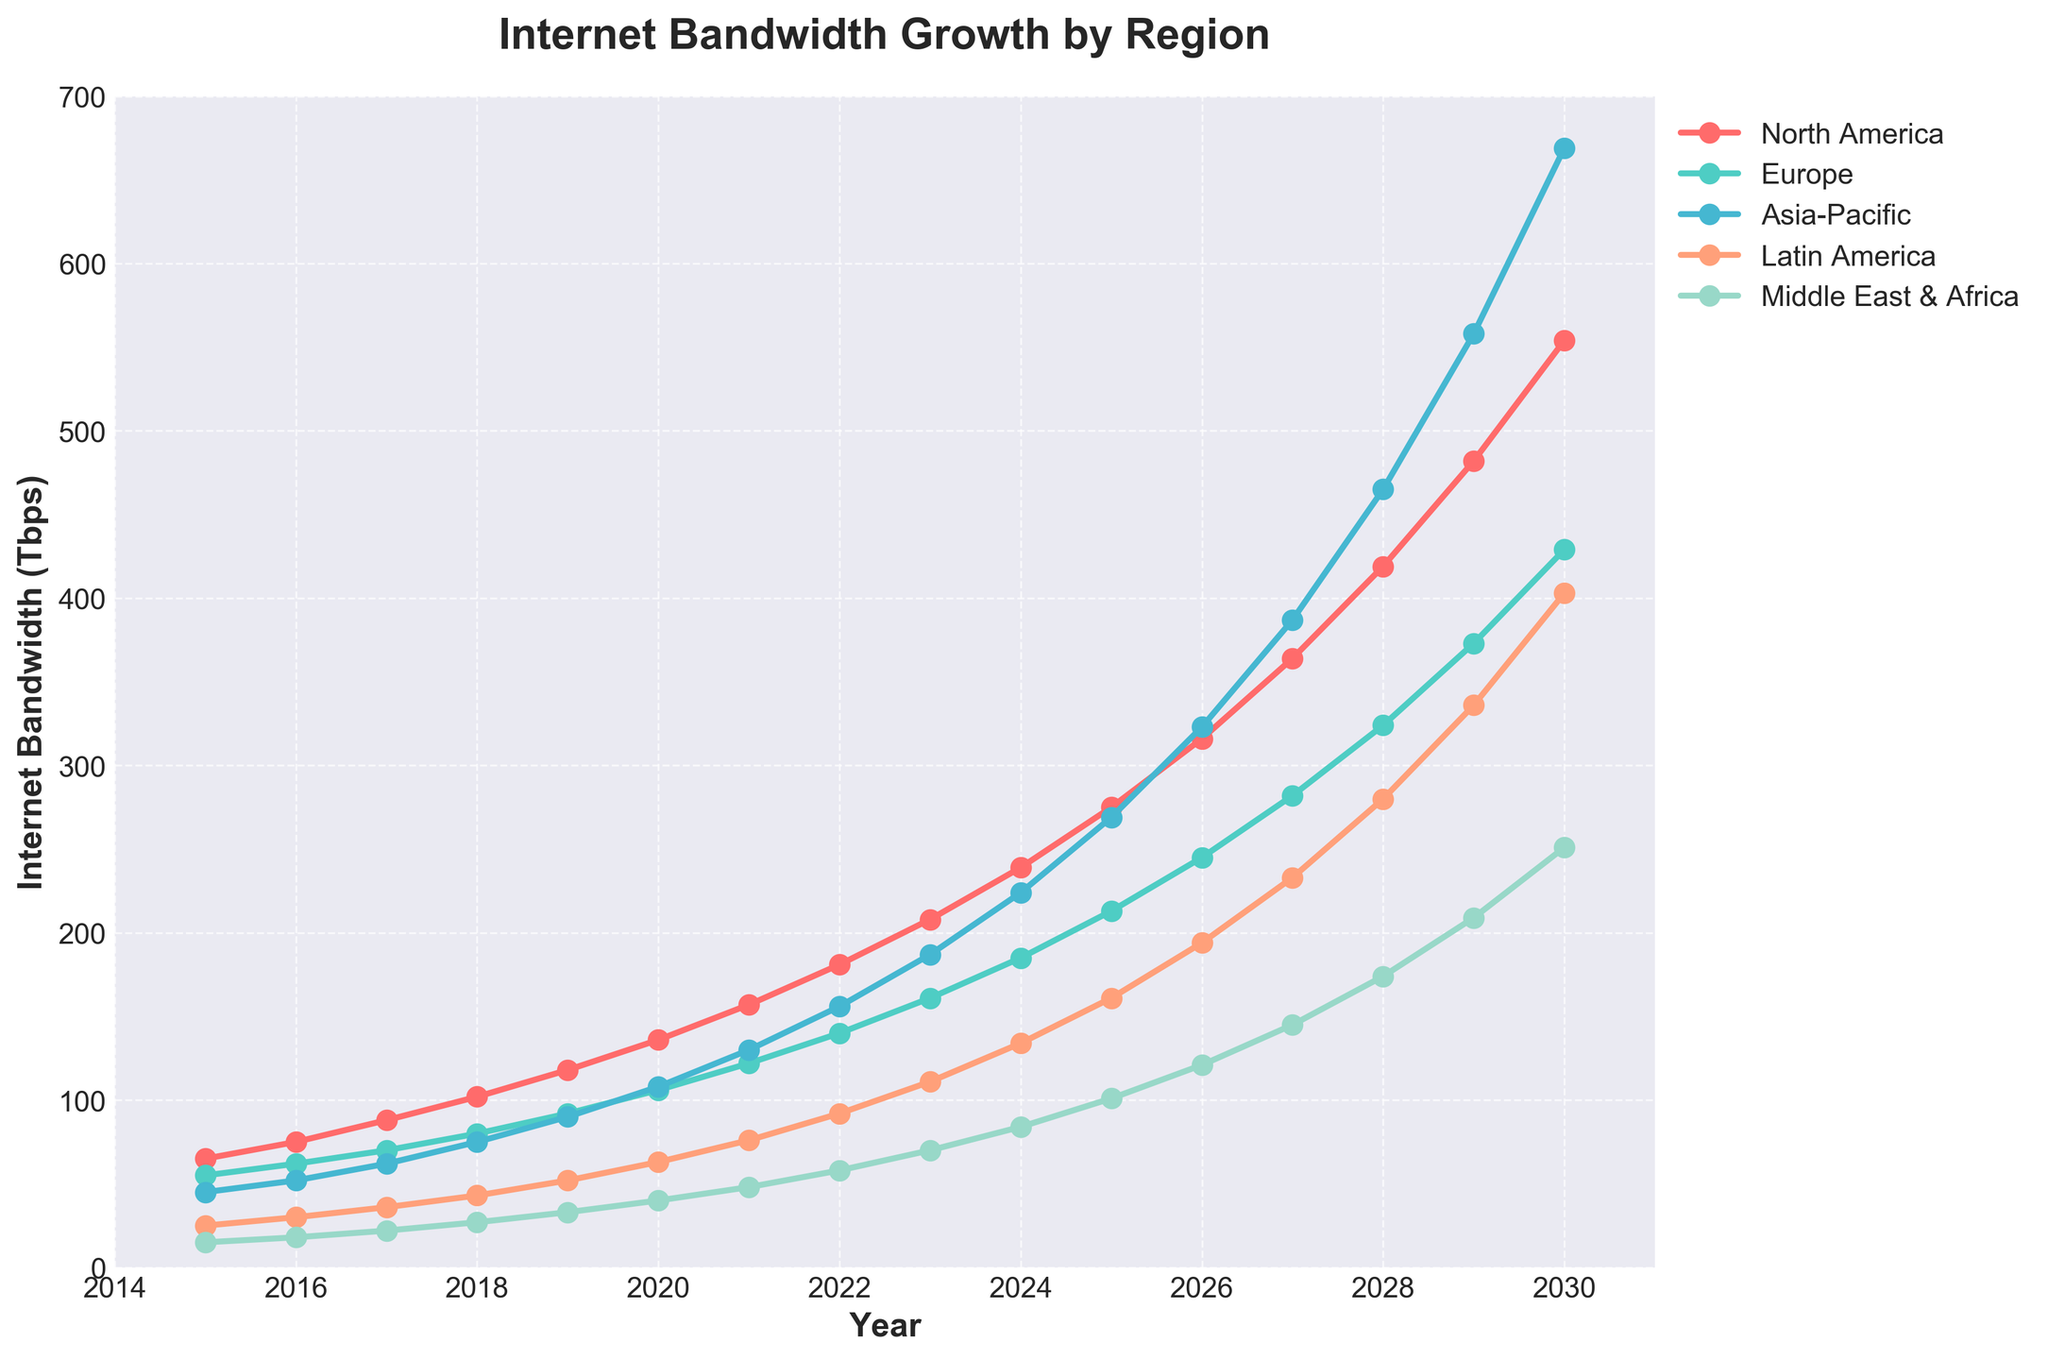What is the overall trend in internet bandwidth for all regions from 2015 to 2030? To determine the overall trend, observe the line graph. All regions show an upward trajectory over the years, indicating a consistent increase in internet bandwidth for each region.
Answer: Upward Which region shows the highest growth in internet bandwidth from 2015 to 2030? To identify this, look at the final values of each region in 2030 and compare them. North America ends at 554 Tbps, Europe at 429 Tbps, Asia-Pacific at 669 Tbps, Latin America at 403 Tbps, and Middle East & Africa at 251 Tbps. Asia-Pacific has the highest value.
Answer: Asia-Pacific How does the internet bandwidth in North America in 2025 compare to that in Europe in the same year? Check the points at 2025 for both North America and Europe. North America is at 275 Tbps, and Europe is at 213 Tbps. Comparing these figures, North America has a higher value.
Answer: North America is higher What's the difference in internet bandwidth between Asia-Pacific and Latin America in 2028? Locate the values for both regions in 2028. Asia-Pacific has 465 Tbps, and Latin America has 280 Tbps. The difference is 465 - 280 = 185 Tbps.
Answer: 185 Tbps What is the average annual bandwidth in Europe from 2015 to 2020? First, sum the yearly bandwidth values for Europe from 2015 to 2020: 55 + 62 + 70 + 80 + 92 + 106 = 465 Tbps. There are 6 years, so divide by 6: 465 / 6 = 77.5 Tbps.
Answer: 77.5 Tbps Identify the region that had the smallest growth in internet bandwidth from 2015 to 2030. Compare the growth by subtracting the 2015 value from the 2030 value for each region. The region with the smallest difference will have the smallest growth: 
- North America: 554 - 65 = 489 
- Europe: 429 - 55 = 374 
- Asia-Pacific: 669 - 45 = 624 
- Latin America: 403 - 25 = 378 
- Middle East & Africa: 251 - 15 = 236 
Middle East & Africa has the smallest growth.
Answer: Middle East & Africa Between which consecutive years does Latin America show the greatest increase in internet bandwidth? Observe the changes year over year for Latin America. The greatest change occurs between consecutive years when the increase is the highest:
- 2015 to 2016: 30 - 25 = 5
- 2016 to 2017: 36 - 30 = 6
- 2017 to 2018: 43 - 36 = 7
- 2018 to 2019: 52 - 43 = 9
- 2019 to 2020: 63 - 52 = 11 **(Largest Increase)**
- Continue the comparison till 2030. The highest increase happens between 2019 and 2020.
Answer: 2019 to 2020 Which year does Asia-Pacific's internet bandwidth surpass 100 Tbps? Find the year when the Asia-Pacific line crosses the 100 Tbps mark. In 2020, Asia-Pacific reaches 108 Tbps, crossing 100 Tbps for the first time.
Answer: 2020 By how much does the internet bandwidth in the Middle East & Africa increase from 2024 to 2027? Look up the values for 2024 and 2027 for Middle East & Africa: 84 Tbps and 145 Tbps, respectively. The increase is 145 - 84 = 61 Tbps.
Answer: 61 Tbps 